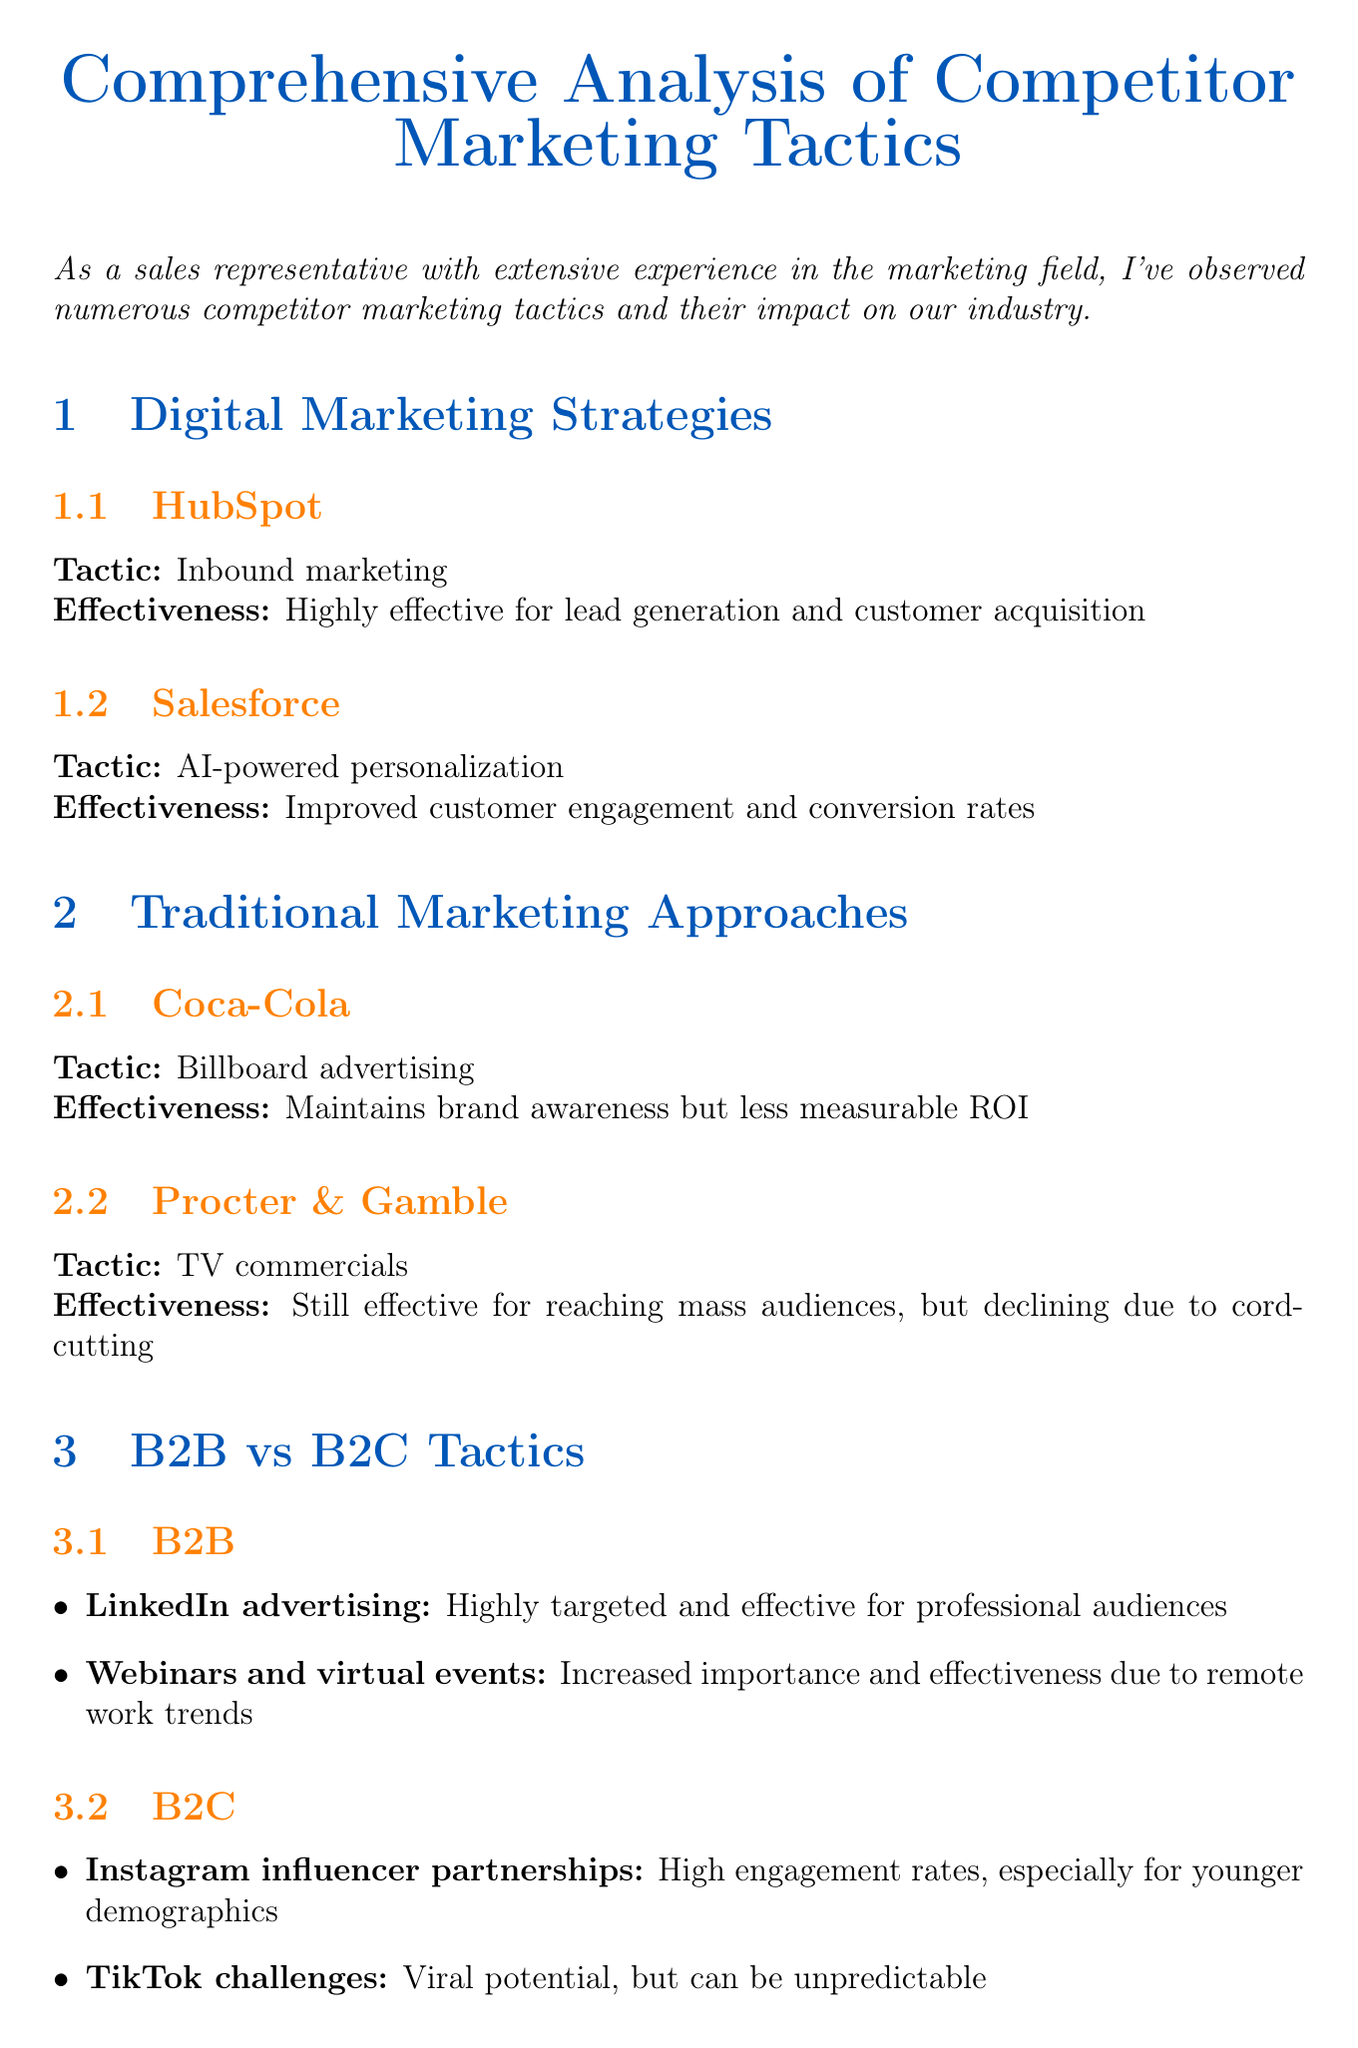What tactic does HubSpot use? HubSpot's tactic is listed under digital marketing strategies in the document.
Answer: Inbound marketing How effective is Salesforce's AI-powered personalization? The document states the effectiveness of this tactic in relation to customer engagement and conversion rates.
Answer: Improved customer engagement and conversion rates What is a challenge faced by YouTube influencers? The document outlines challenges for YouTube as a platform in the influencer marketing section.
Answer: Increasing competition and ad fatigue What is the effectiveness of LinkedIn advertising in B2B tactics? This effectiveness is specifically mentioned in the B2B tactics section of the document.
Answer: Highly targeted and effective for professional audiences How does Red Bull create content? Red Bull's strategy is elaborated in the content marketing strategies section of the document.
Answer: Extreme sports content creation What is a market challenge mentioned in the document? Challenges faced by marketers are listed in the market challenges section.
Answer: Increasing ad costs on major platforms like Google and Facebook How does Coca-Cola maintain brand awareness? Coca-Cola's traditional marketing tactic is described in the document.
Answer: Billboard advertising What is the Return on Ad Spend? This term is listed in the effectiveness metrics section as one of the metrics used to evaluate marketing effectiveness.
Answer: ROAS 